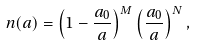<formula> <loc_0><loc_0><loc_500><loc_500>n ( a ) = \left ( 1 - \frac { a _ { 0 } } { a } \right ) ^ { M } \left ( \frac { a _ { 0 } } { a } \right ) ^ { N } ,</formula> 